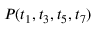Convert formula to latex. <formula><loc_0><loc_0><loc_500><loc_500>P ( t _ { 1 } , t _ { 3 } , t _ { 5 } , t _ { 7 } )</formula> 